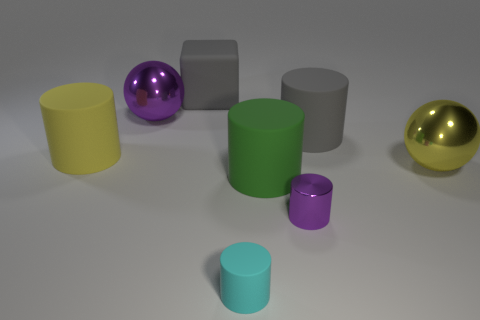Are there more large cylinders that are right of the large purple metal thing than spheres?
Keep it short and to the point. No. Do the cyan cylinder and the green object have the same size?
Keep it short and to the point. No. The small cylinder that is made of the same material as the large block is what color?
Provide a short and direct response. Cyan. There is a matte object that is the same color as the big cube; what shape is it?
Offer a terse response. Cylinder. Are there an equal number of big yellow cylinders that are behind the purple metal ball and yellow metal things left of the metal cylinder?
Provide a succinct answer. Yes. There is a metallic thing that is behind the big matte cylinder that is behind the yellow cylinder; what shape is it?
Your answer should be very brief. Sphere. There is a purple object that is the same shape as the tiny cyan object; what is its material?
Offer a terse response. Metal. The other shiny sphere that is the same size as the purple metal sphere is what color?
Provide a short and direct response. Yellow. Is the number of green rubber cylinders that are to the right of the large green matte thing the same as the number of large gray blocks?
Ensure brevity in your answer.  No. There is a metal sphere that is in front of the purple object on the left side of the tiny cyan cylinder; what color is it?
Provide a succinct answer. Yellow. 